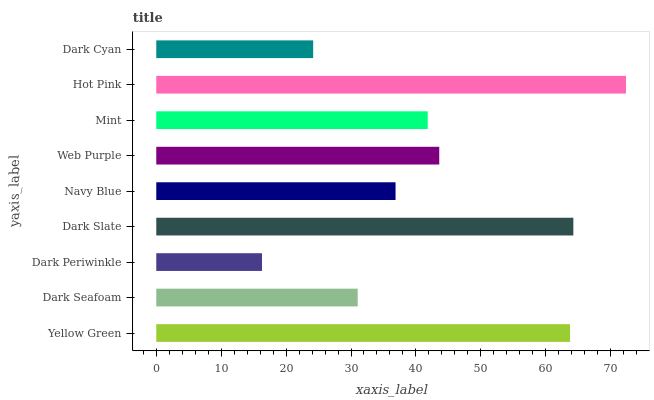Is Dark Periwinkle the minimum?
Answer yes or no. Yes. Is Hot Pink the maximum?
Answer yes or no. Yes. Is Dark Seafoam the minimum?
Answer yes or no. No. Is Dark Seafoam the maximum?
Answer yes or no. No. Is Yellow Green greater than Dark Seafoam?
Answer yes or no. Yes. Is Dark Seafoam less than Yellow Green?
Answer yes or no. Yes. Is Dark Seafoam greater than Yellow Green?
Answer yes or no. No. Is Yellow Green less than Dark Seafoam?
Answer yes or no. No. Is Mint the high median?
Answer yes or no. Yes. Is Mint the low median?
Answer yes or no. Yes. Is Dark Seafoam the high median?
Answer yes or no. No. Is Yellow Green the low median?
Answer yes or no. No. 